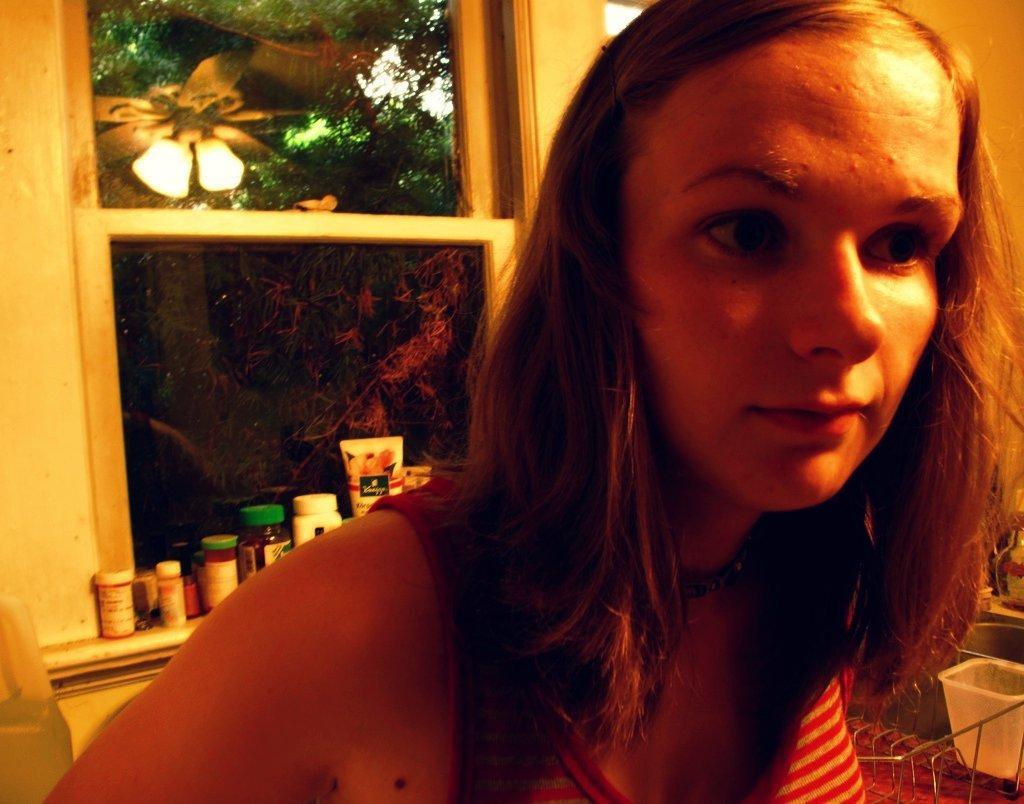Could you give a brief overview of what you see in this image? In this image I can see the person. In the background I can see the tubes and many jars on the window. To the right I can see some baskets. I can see the trees through the window. 